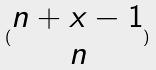<formula> <loc_0><loc_0><loc_500><loc_500>( \begin{matrix} n + x - 1 \\ n \end{matrix} )</formula> 